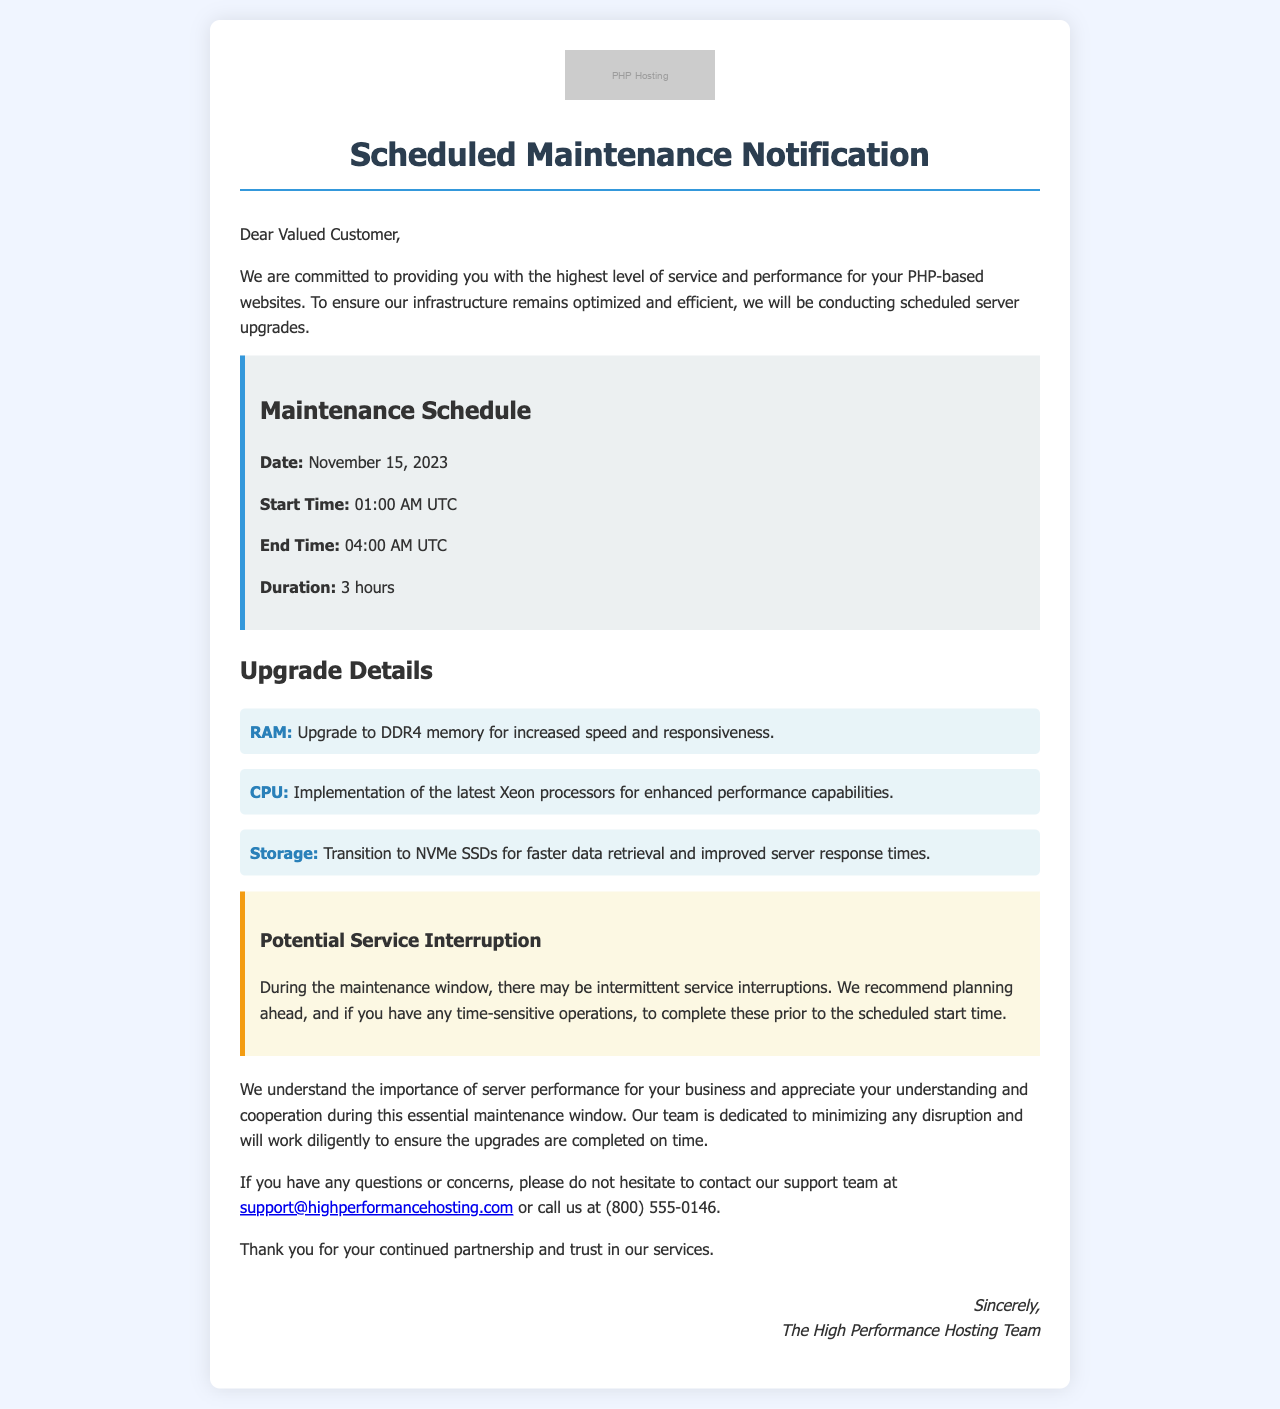What is the date of the scheduled maintenance? The date of the scheduled maintenance is mentioned in the maintenance schedule section of the document.
Answer: November 15, 2023 What is the duration of the scheduled maintenance? The duration of the scheduled maintenance is specified in the maintenance schedule section as the time from start to end.
Answer: 3 hours What time does the maintenance start? The start time for the maintenance is clearly stated in the document.
Answer: 01:00 AM UTC What upgrade component is mentioned for increased speed? The document lists upgrades and specifies which component is related to speed enhancement.
Answer: RAM Which type of processors will be implemented? The document details the enhancements and mentions the type of processors planned for implementation.
Answer: Xeon processors What is a potential impact during the maintenance window? The document includes a section that warns about the possible result of the maintenance activities.
Answer: Intermittent service interruptions What storage technology is being transitioned to? The upgrade details in the document specify the type of storage technology that will be used for improvements.
Answer: NVMe SSDs Who should customers contact for support? The document provides specific contact information for customer support.
Answer: support@highperformancehosting.com 